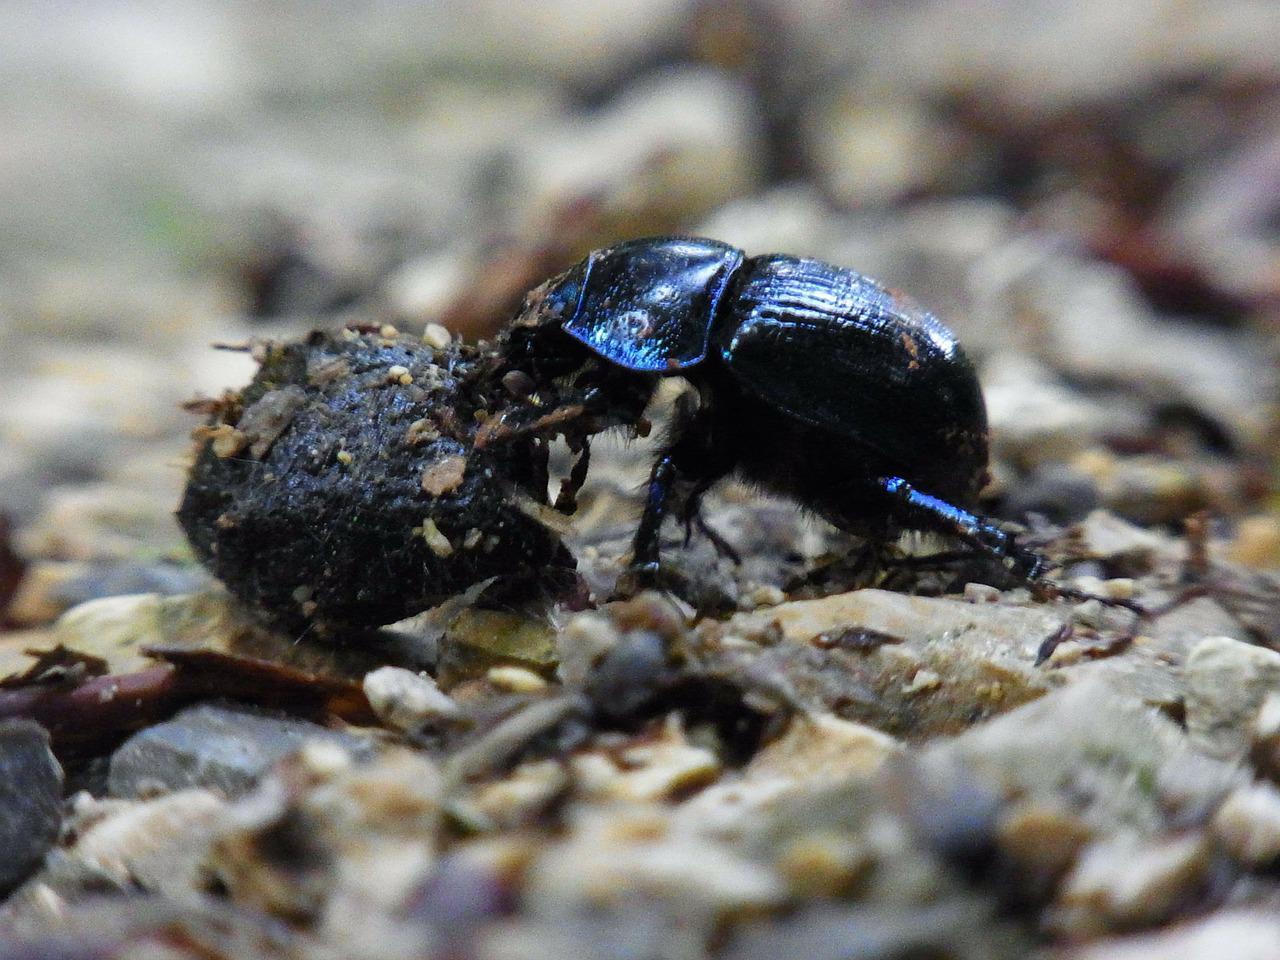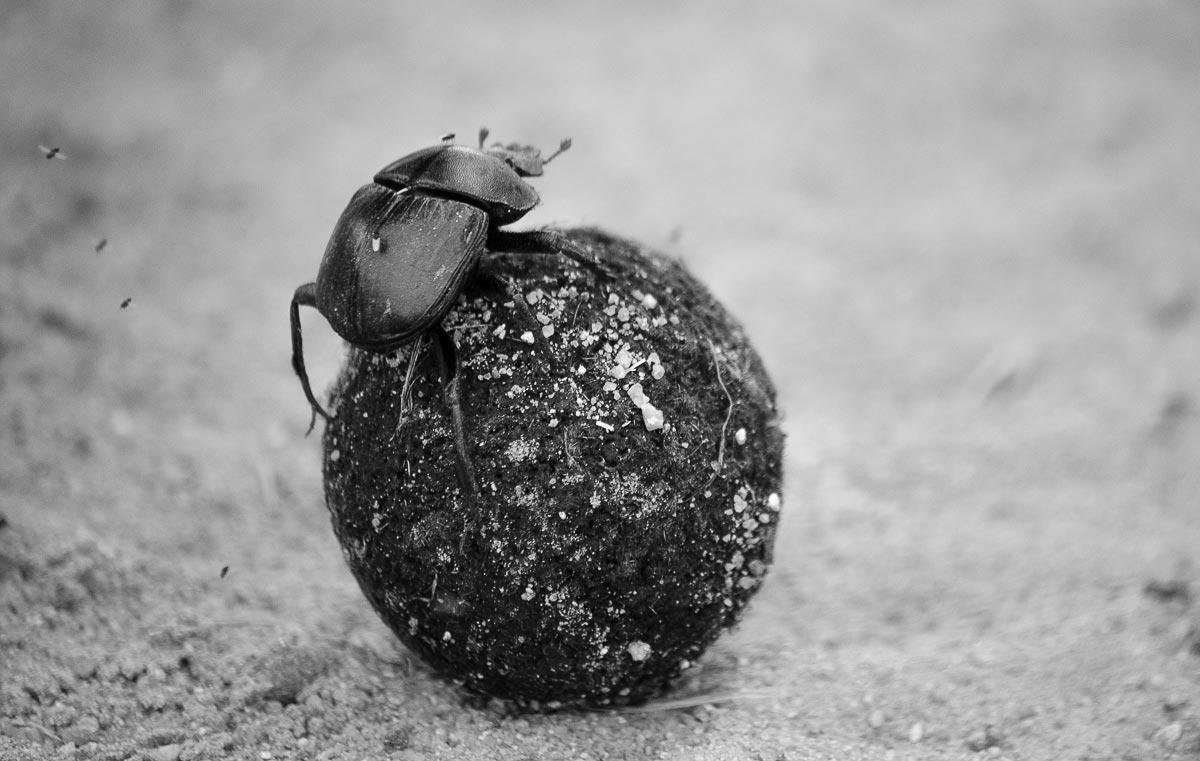The first image is the image on the left, the second image is the image on the right. For the images shown, is this caption "In one image there is a dung beetle on the right side of the dung ball with its head toward the ground." true? Answer yes or no. No. The first image is the image on the left, the second image is the image on the right. Considering the images on both sides, is "A dug beetle with a ball of dug is pictured in black and white." valid? Answer yes or no. Yes. 